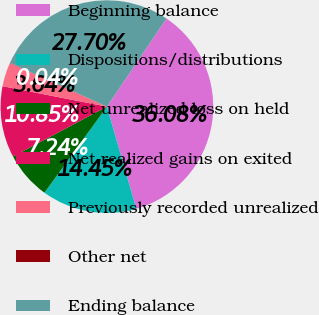Convert chart. <chart><loc_0><loc_0><loc_500><loc_500><pie_chart><fcel>Beginning balance<fcel>Dispositions/distributions<fcel>Net unrealized loss on held<fcel>Net realized gains on exited<fcel>Previously recorded unrealized<fcel>Other net<fcel>Ending balance<nl><fcel>36.08%<fcel>14.45%<fcel>7.24%<fcel>10.85%<fcel>3.64%<fcel>0.04%<fcel>27.7%<nl></chart> 